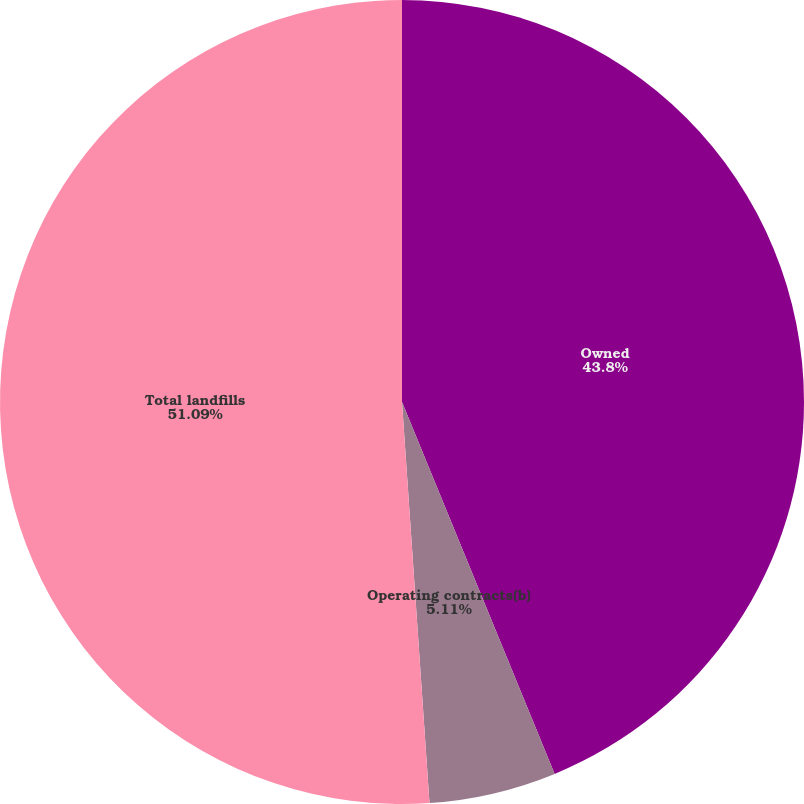Convert chart to OTSL. <chart><loc_0><loc_0><loc_500><loc_500><pie_chart><fcel>Owned<fcel>Operating contracts(b)<fcel>Total landfills<nl><fcel>43.8%<fcel>5.11%<fcel>51.09%<nl></chart> 